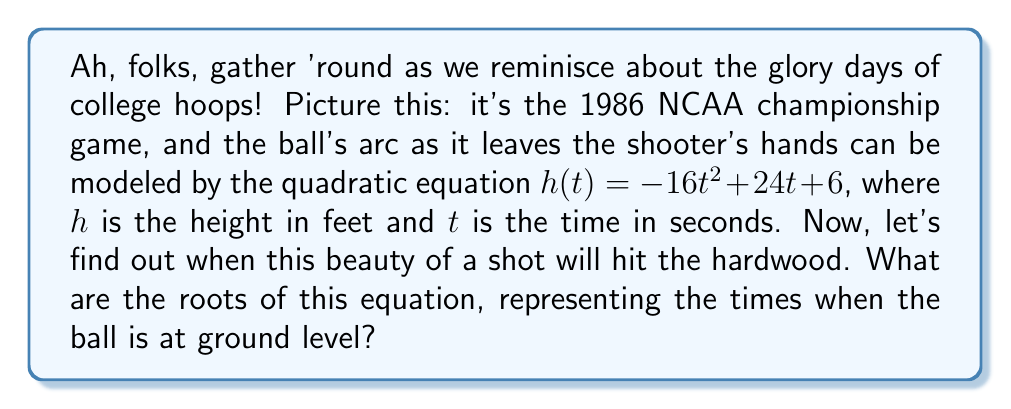Teach me how to tackle this problem. Alright, basketball fans, let's break this down play-by-play:

1) We're looking for the roots of the equation $h(t) = -16t^2 + 24t + 6$. These roots occur when $h(t) = 0$, as that's when the ball hits the ground.

2) So, we need to solve: $0 = -16t^2 + 24t + 6$

3) This is a quadratic equation in the standard form $ax^2 + bx + c = 0$, where:
   $a = -16$, $b = 24$, and $c = 6$

4) We can solve this using the quadratic formula: $t = \frac{-b \pm \sqrt{b^2 - 4ac}}{2a}$

5) Let's substitute our values:
   $$t = \frac{-24 \pm \sqrt{24^2 - 4(-16)(6)}}{2(-16)}$$

6) Simplify under the square root:
   $$t = \frac{-24 \pm \sqrt{576 + 384}}{-32} = \frac{-24 \pm \sqrt{960}}{-32}$$

7) Simplify further:
   $$t = \frac{-24 \pm 4\sqrt{60}}{-32}$$

8) Divide both numerator and denominator by -8:
   $$t = \frac{3 \mp \frac{1}{2}\sqrt{60}}{4}$$

9) This gives us two solutions:
   $$t_1 = \frac{3 + \frac{1}{2}\sqrt{60}}{4} \approx 1.93$$
   $$t_2 = \frac{3 - \frac{1}{2}\sqrt{60}}{4} \approx 0.07$$

These times represent when the ball is released (about 0.07 seconds) and when it hits the ground (about 1.93 seconds).
Answer: The roots of the equation are $t_1 = \frac{3 + \frac{1}{2}\sqrt{60}}{4}$ and $t_2 = \frac{3 - \frac{1}{2}\sqrt{60}}{4}$. 